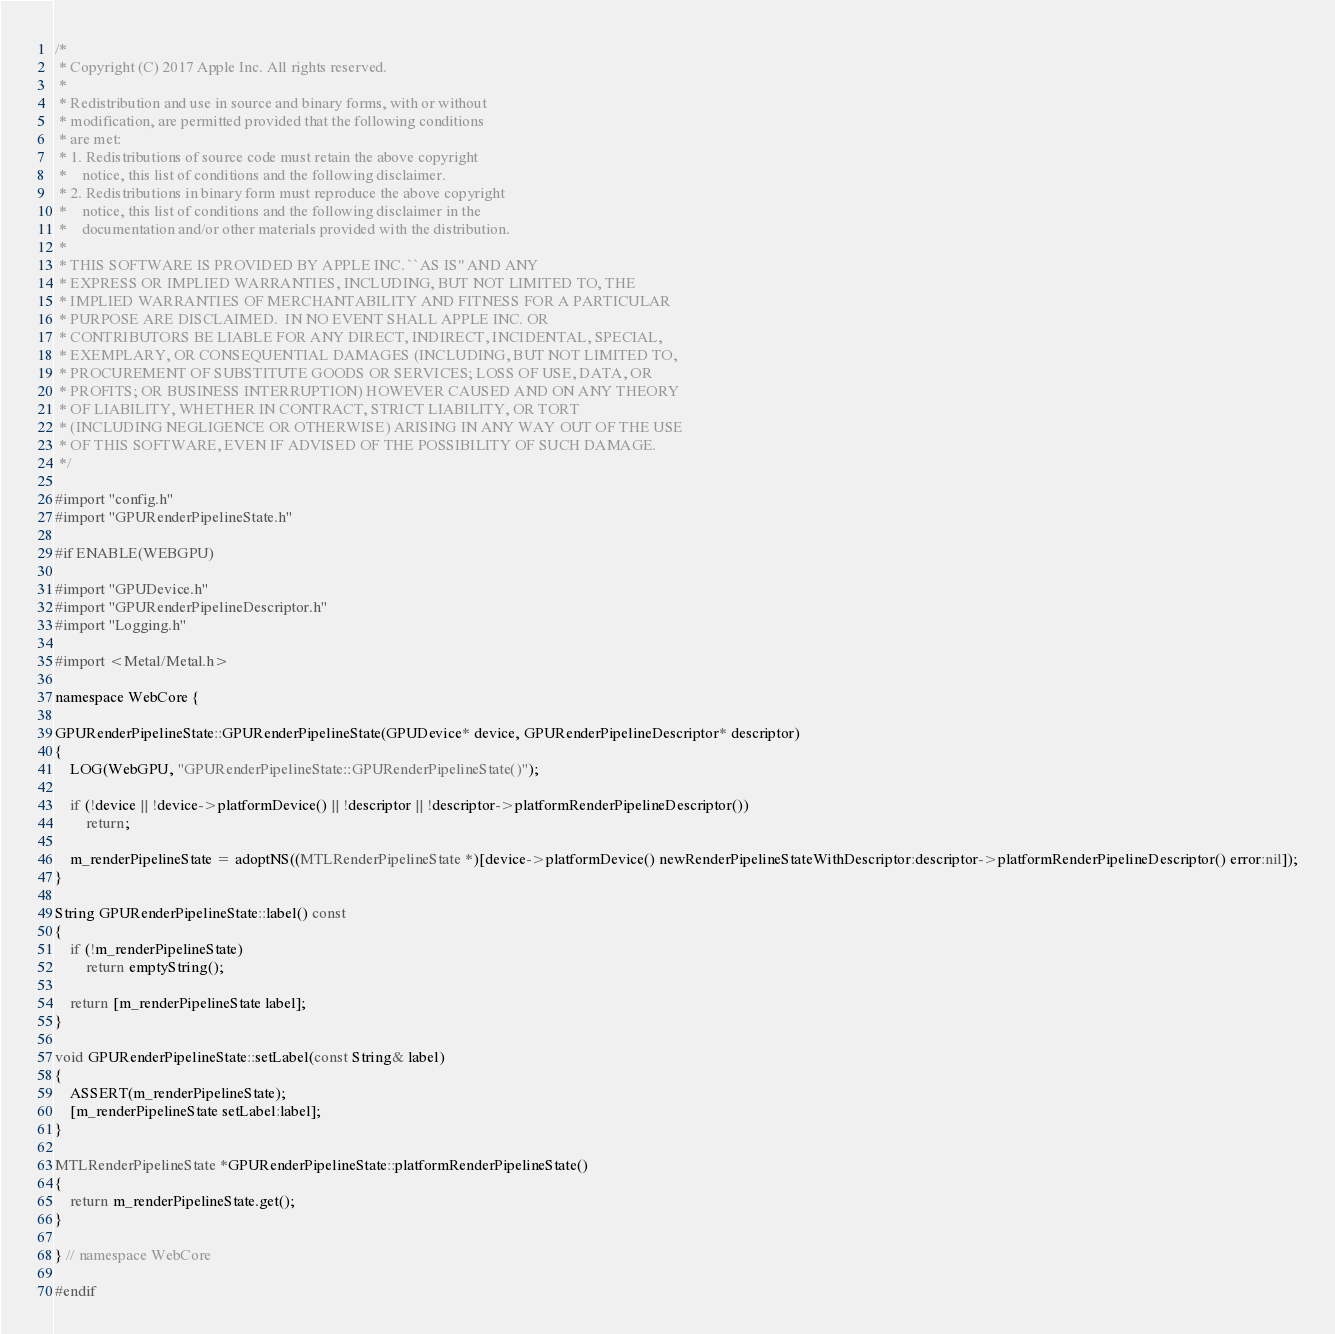<code> <loc_0><loc_0><loc_500><loc_500><_ObjectiveC_>/*
 * Copyright (C) 2017 Apple Inc. All rights reserved.
 *
 * Redistribution and use in source and binary forms, with or without
 * modification, are permitted provided that the following conditions
 * are met:
 * 1. Redistributions of source code must retain the above copyright
 *    notice, this list of conditions and the following disclaimer.
 * 2. Redistributions in binary form must reproduce the above copyright
 *    notice, this list of conditions and the following disclaimer in the
 *    documentation and/or other materials provided with the distribution.
 *
 * THIS SOFTWARE IS PROVIDED BY APPLE INC. ``AS IS'' AND ANY
 * EXPRESS OR IMPLIED WARRANTIES, INCLUDING, BUT NOT LIMITED TO, THE
 * IMPLIED WARRANTIES OF MERCHANTABILITY AND FITNESS FOR A PARTICULAR
 * PURPOSE ARE DISCLAIMED.  IN NO EVENT SHALL APPLE INC. OR
 * CONTRIBUTORS BE LIABLE FOR ANY DIRECT, INDIRECT, INCIDENTAL, SPECIAL,
 * EXEMPLARY, OR CONSEQUENTIAL DAMAGES (INCLUDING, BUT NOT LIMITED TO,
 * PROCUREMENT OF SUBSTITUTE GOODS OR SERVICES; LOSS OF USE, DATA, OR
 * PROFITS; OR BUSINESS INTERRUPTION) HOWEVER CAUSED AND ON ANY THEORY
 * OF LIABILITY, WHETHER IN CONTRACT, STRICT LIABILITY, OR TORT
 * (INCLUDING NEGLIGENCE OR OTHERWISE) ARISING IN ANY WAY OUT OF THE USE
 * OF THIS SOFTWARE, EVEN IF ADVISED OF THE POSSIBILITY OF SUCH DAMAGE.
 */

#import "config.h"
#import "GPURenderPipelineState.h"

#if ENABLE(WEBGPU)

#import "GPUDevice.h"
#import "GPURenderPipelineDescriptor.h"
#import "Logging.h"

#import <Metal/Metal.h>

namespace WebCore {

GPURenderPipelineState::GPURenderPipelineState(GPUDevice* device, GPURenderPipelineDescriptor* descriptor)
{
    LOG(WebGPU, "GPURenderPipelineState::GPURenderPipelineState()");

    if (!device || !device->platformDevice() || !descriptor || !descriptor->platformRenderPipelineDescriptor())
        return;

    m_renderPipelineState = adoptNS((MTLRenderPipelineState *)[device->platformDevice() newRenderPipelineStateWithDescriptor:descriptor->platformRenderPipelineDescriptor() error:nil]);
}

String GPURenderPipelineState::label() const
{
    if (!m_renderPipelineState)
        return emptyString();

    return [m_renderPipelineState label];
}

void GPURenderPipelineState::setLabel(const String& label)
{
    ASSERT(m_renderPipelineState);
    [m_renderPipelineState setLabel:label];
}
    
MTLRenderPipelineState *GPURenderPipelineState::platformRenderPipelineState()
{
    return m_renderPipelineState.get();
}

} // namespace WebCore

#endif
</code> 